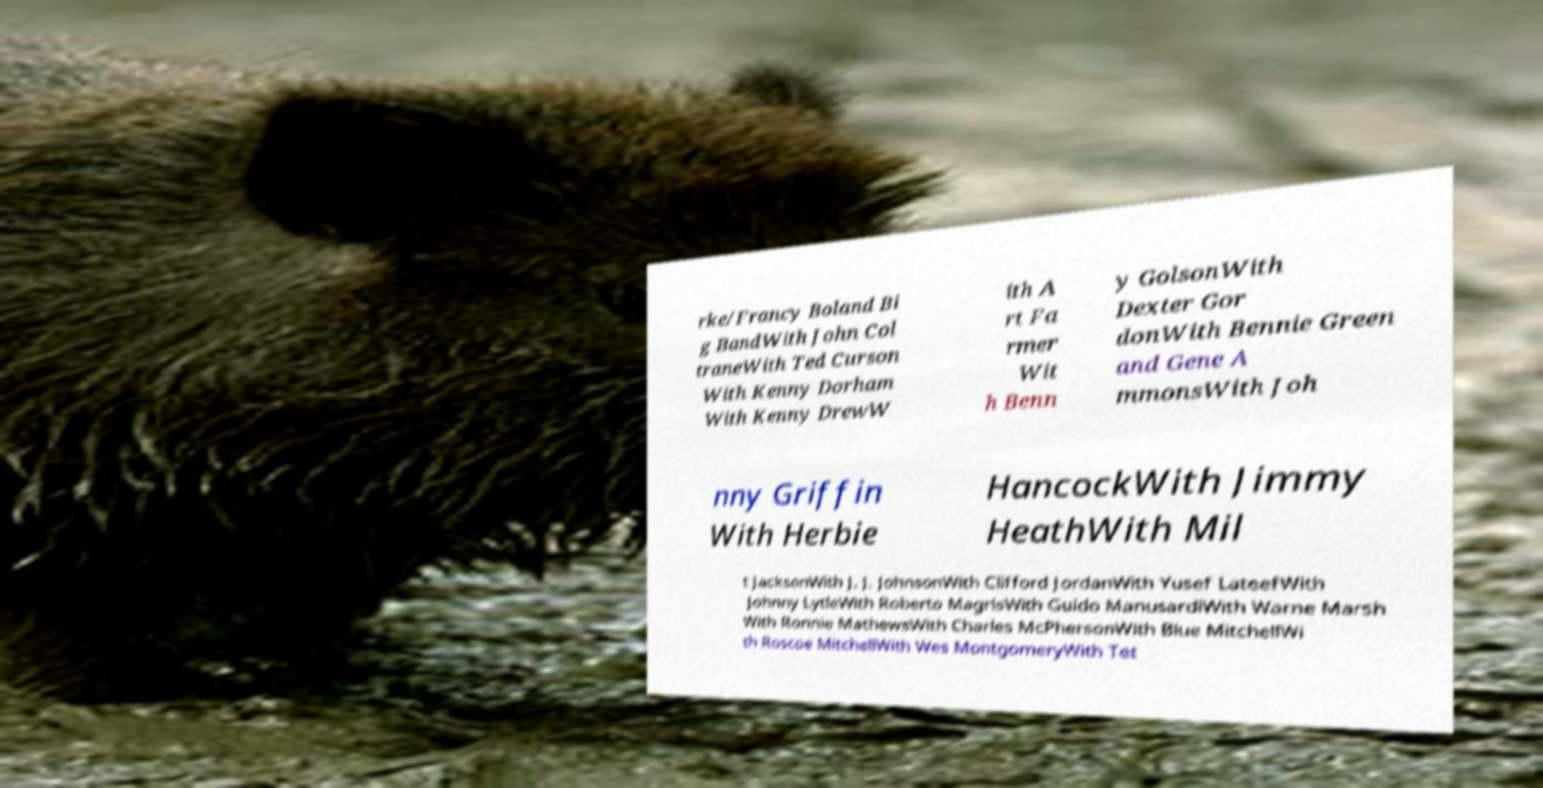For documentation purposes, I need the text within this image transcribed. Could you provide that? rke/Francy Boland Bi g BandWith John Col traneWith Ted Curson With Kenny Dorham With Kenny DrewW ith A rt Fa rmer Wit h Benn y GolsonWith Dexter Gor donWith Bennie Green and Gene A mmonsWith Joh nny Griffin With Herbie HancockWith Jimmy HeathWith Mil t JacksonWith J. J. JohnsonWith Clifford JordanWith Yusef LateefWith Johnny LytleWith Roberto MagrisWith Guido ManusardiWith Warne Marsh With Ronnie MathewsWith Charles McPhersonWith Blue MitchellWi th Roscoe MitchellWith Wes MontgomeryWith Tet 